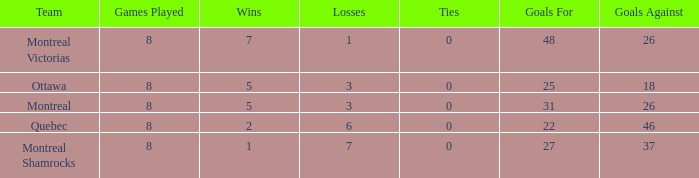How many losses were faced by the team with 22 goals made and more than 8 games participated in? 0.0. 